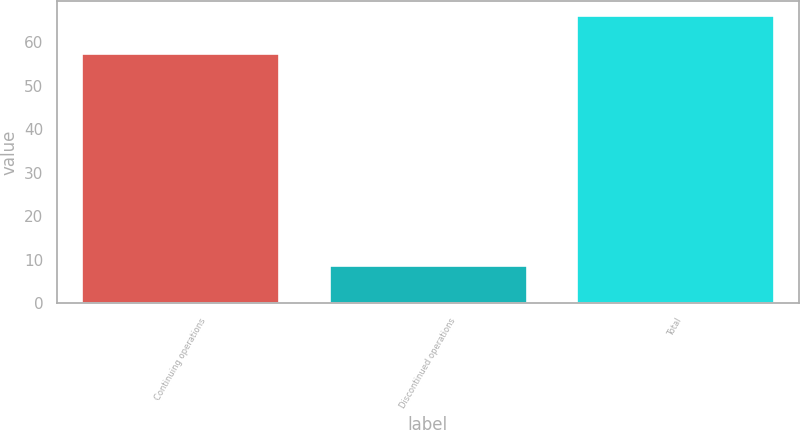Convert chart. <chart><loc_0><loc_0><loc_500><loc_500><bar_chart><fcel>Continuing operations<fcel>Discontinued operations<fcel>Total<nl><fcel>57.5<fcel>8.8<fcel>66.3<nl></chart> 